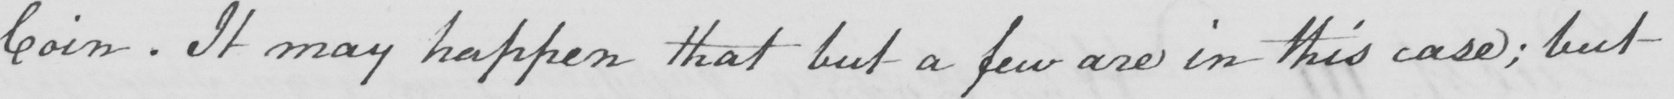Please provide the text content of this handwritten line. Coin . It may happen that but a few are in this case ; but 